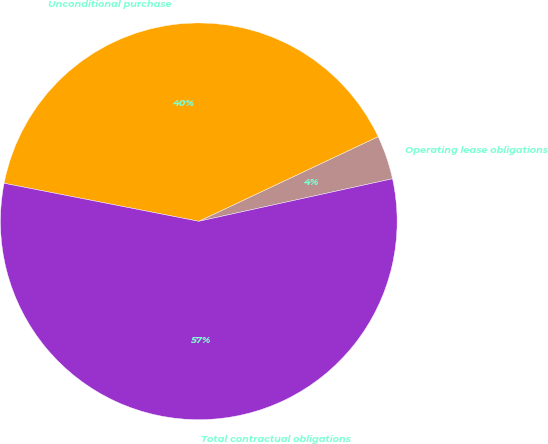Convert chart. <chart><loc_0><loc_0><loc_500><loc_500><pie_chart><fcel>Operating lease obligations<fcel>Unconditional purchase<fcel>Total contractual obligations<nl><fcel>3.58%<fcel>39.91%<fcel>56.51%<nl></chart> 